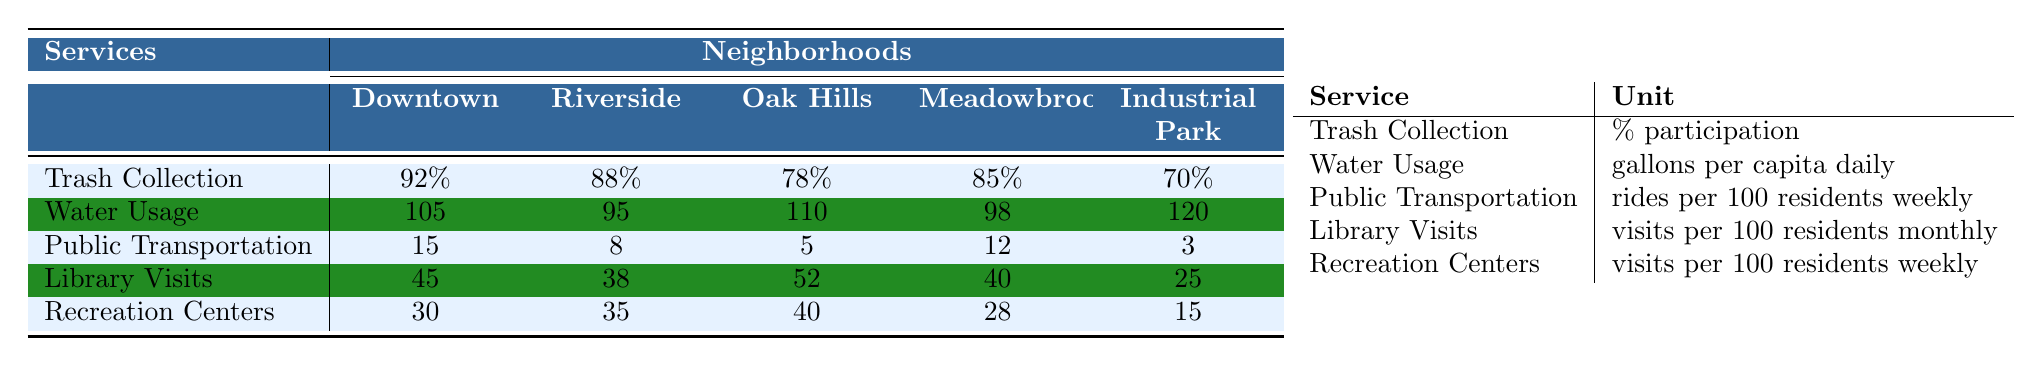What is the participation rate for Trash Collection in Riverside? The participation rate for Trash Collection in Riverside is listed directly in the table. It shows 88% participation.
Answer: 88% Which neighborhood has the highest Water Usage? The table lists Water Usage values for all neighborhoods. Riverside has the highest value at 95 gallons per capita daily, compared to others.
Answer: Riverside What is the average Library Visits across all neighborhoods? To find the average, first add the Library Visits for all neighborhoods: 45 + 38 + 52 + 40 + 25 = 200. Then divide by the number of neighborhoods (5): 200/5 = 40.
Answer: 40 Is the participation rate for Trash Collection lower than 80% in any neighborhood? Looking at the participation rates for Trash Collection, Oak Hills has a rate of 78%, which is lower than 80%.
Answer: Yes What is the total number of rides provided by Public Transportation in the Downtown and Meadowbrook neighborhoods combined? From the table, Public Transportation rides are 15 in Downtown and 12 in Meadowbrook. Adding them gives: 15 + 12 = 27 rides.
Answer: 27 What is the median Recreation Centers visits across all neighborhoods? First, we list the visits: 30, 35, 40, 28, 15. Sorting them gives: 15, 28, 30, 35, 40. The median is the middle value, which is 30.
Answer: 30 Which neighborhood uses the least amount of Water? The data for Water Usage shows Oak Hills with the least amount at 110 gallons per capita daily compared to others.
Answer: Oak Hills How does the participation rate for Trash Collection in Downtown compare to Meadowbrook? The participation rates are 92% for Downtown and 85% for Meadowbrook. Downtown has a higher rate compared to Meadowbrook.
Answer: Higher What is the difference in Library Visits between Riverside and Industrial Park? Riverside has 38 visits and Industrial Park has 25 visits. Subtracting gives 38 - 25 = 13 visits difference.
Answer: 13 Which service has the highest participation rate? The highest participation rate listed is for Trash Collection in Downtown at 92%.
Answer: Trash Collection in Downtown 